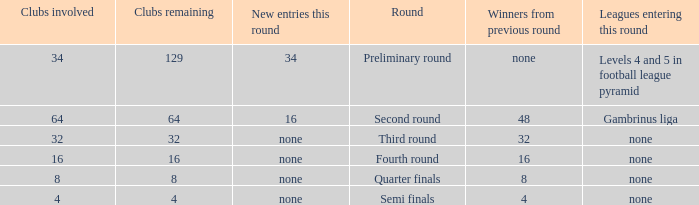Could you parse the entire table as a dict? {'header': ['Clubs involved', 'Clubs remaining', 'New entries this round', 'Round', 'Winners from previous round', 'Leagues entering this round'], 'rows': [['34', '129', '34', 'Preliminary round', 'none', 'Levels 4 and 5 in football league pyramid'], ['64', '64', '16', 'Second round', '48', 'Gambrinus liga'], ['32', '32', 'none', 'Third round', '32', 'none'], ['16', '16', 'none', 'Fourth round', '16', 'none'], ['8', '8', 'none', 'Quarter finals', '8', 'none'], ['4', '4', 'none', 'Semi finals', '4', 'none']]} Name the leagues entering this round for 4 None. 